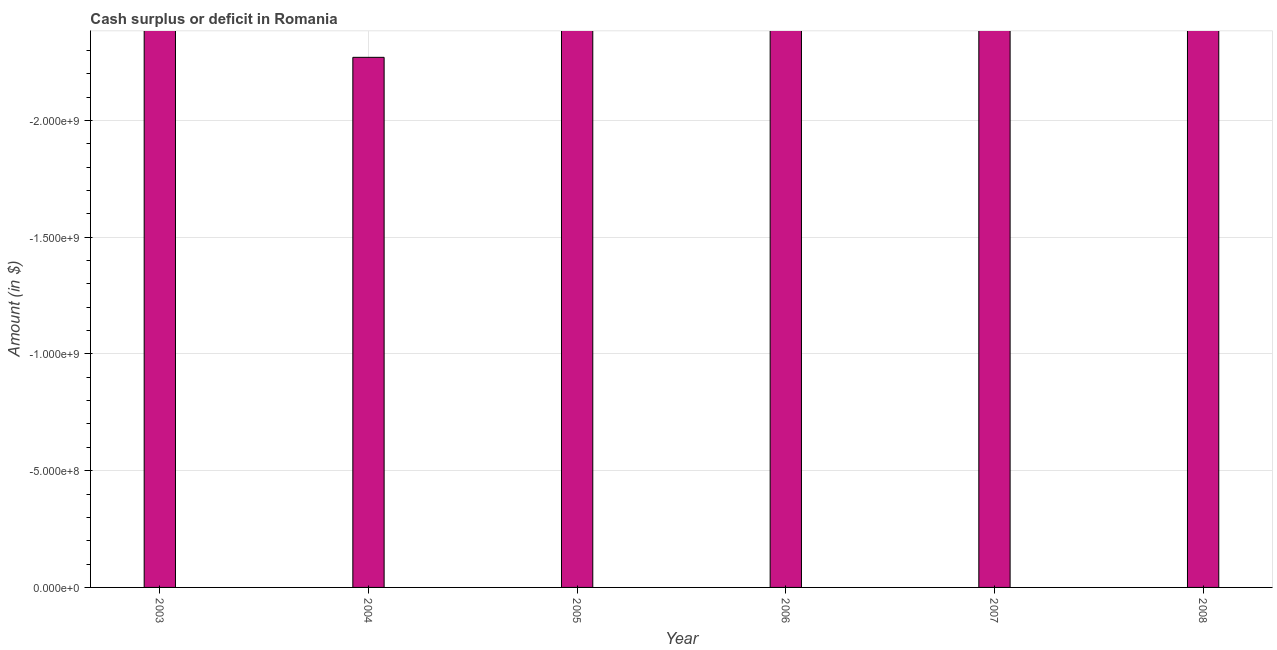What is the title of the graph?
Offer a very short reply. Cash surplus or deficit in Romania. What is the label or title of the X-axis?
Your answer should be very brief. Year. What is the label or title of the Y-axis?
Give a very brief answer. Amount (in $). What is the cash surplus or deficit in 2006?
Give a very brief answer. 0. Across all years, what is the minimum cash surplus or deficit?
Offer a terse response. 0. What is the sum of the cash surplus or deficit?
Your response must be concise. 0. What is the average cash surplus or deficit per year?
Your response must be concise. 0. What is the median cash surplus or deficit?
Offer a terse response. 0. In how many years, is the cash surplus or deficit greater than -1700000000 $?
Offer a very short reply. 0. How many years are there in the graph?
Keep it short and to the point. 6. Are the values on the major ticks of Y-axis written in scientific E-notation?
Offer a very short reply. Yes. What is the Amount (in $) in 2004?
Ensure brevity in your answer.  0. 